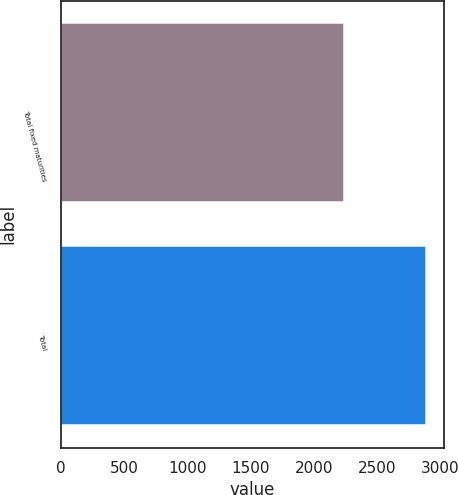<chart> <loc_0><loc_0><loc_500><loc_500><bar_chart><fcel>Total fixed maturities<fcel>Total<nl><fcel>2237<fcel>2885<nl></chart> 